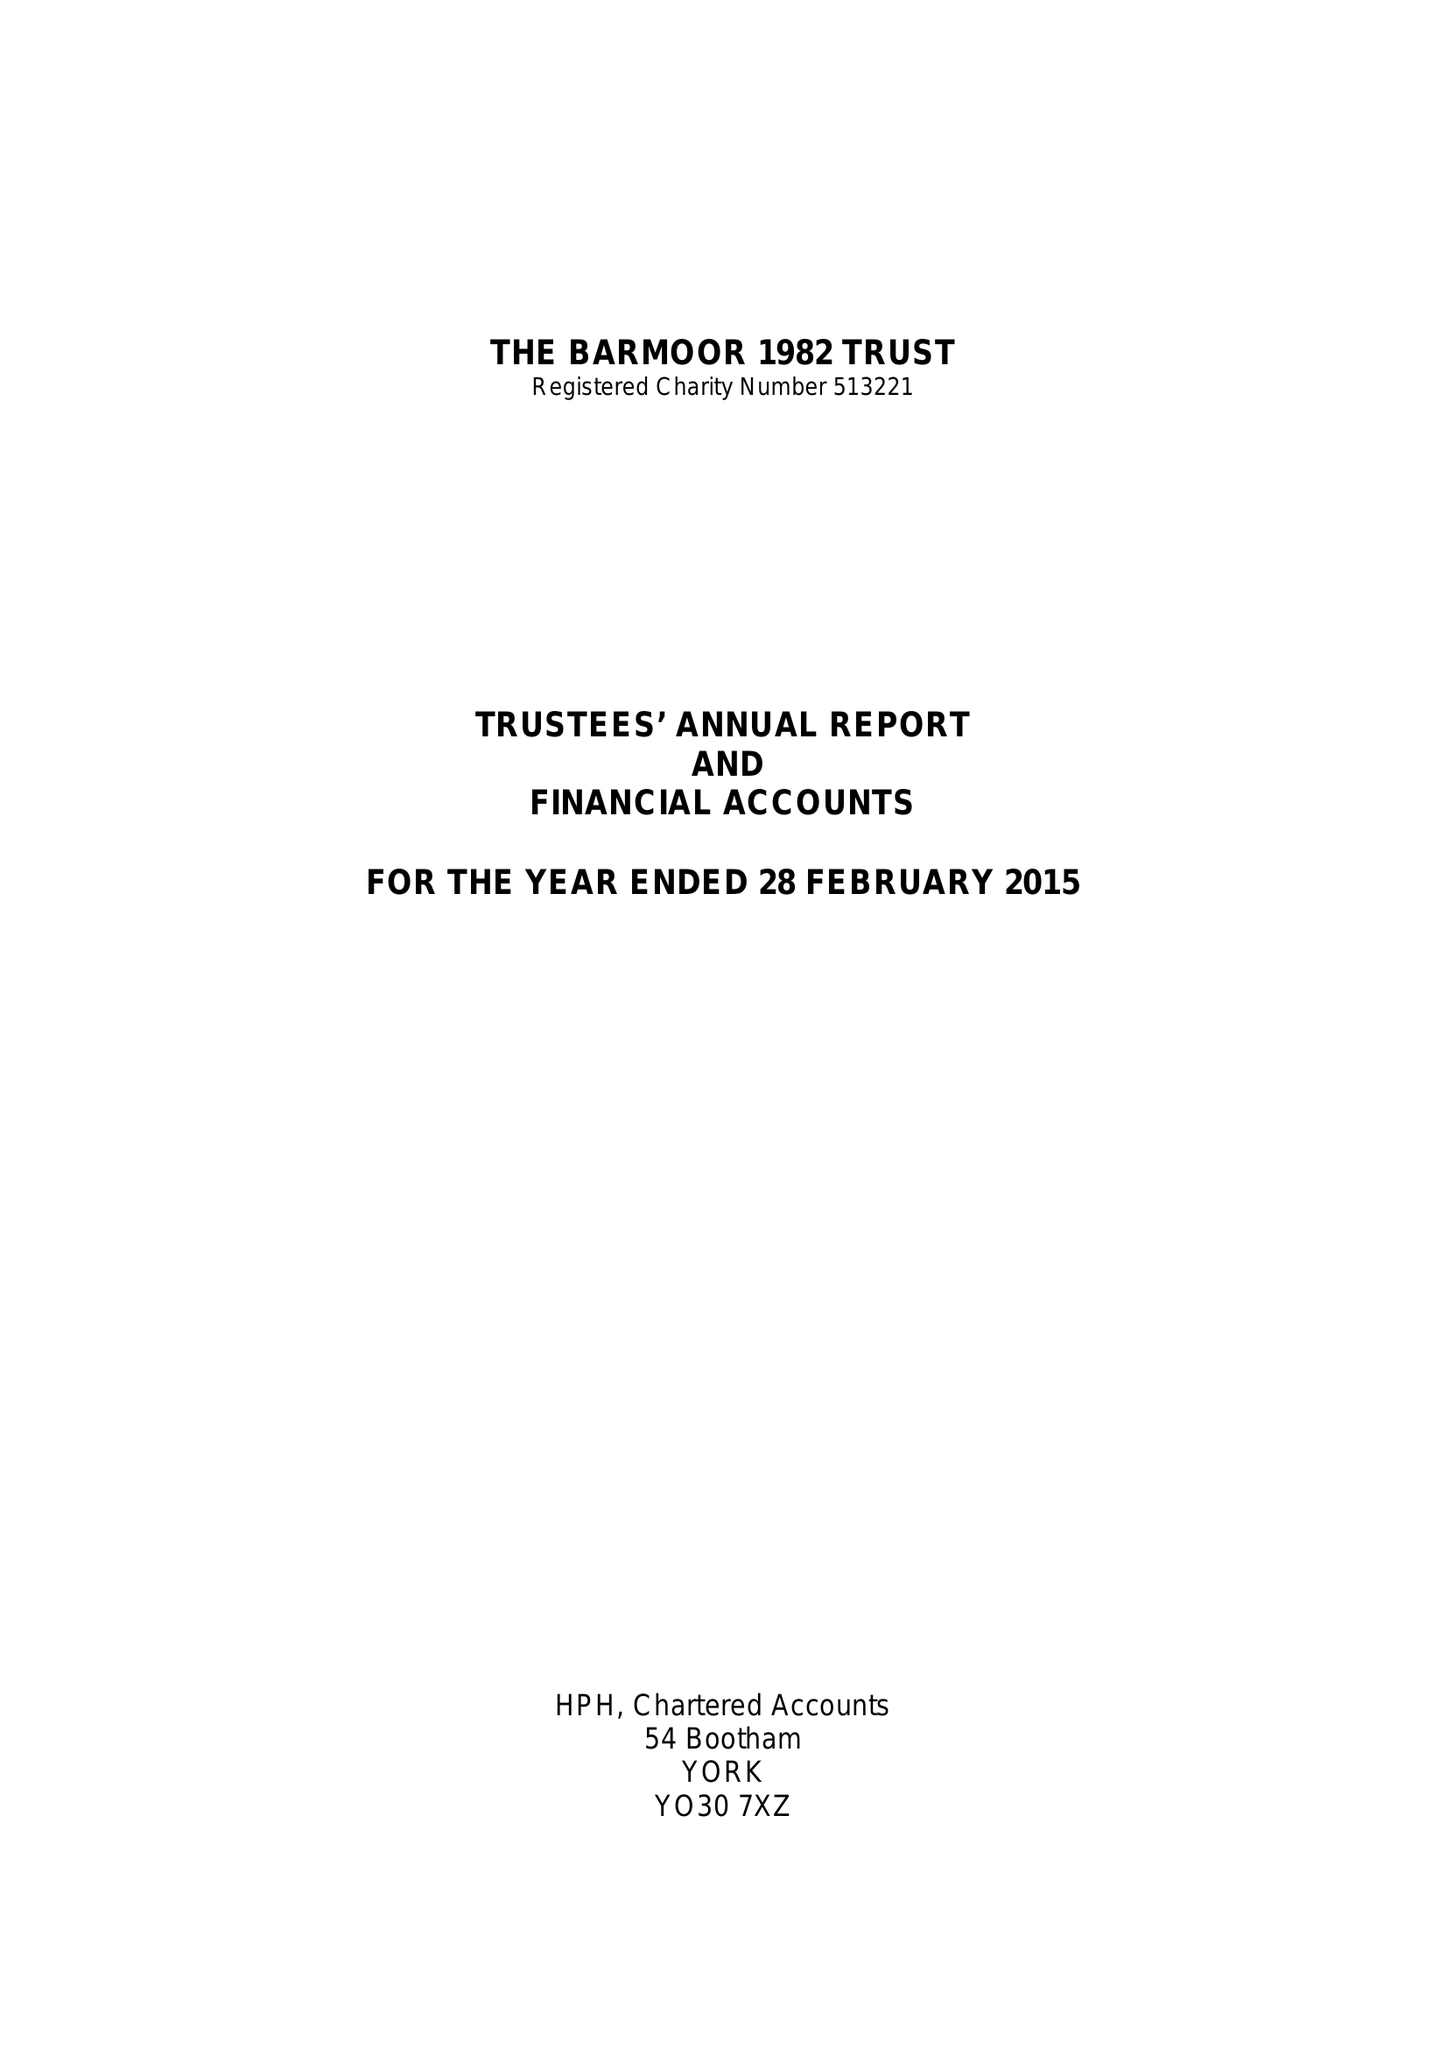What is the value for the charity_name?
Answer the question using a single word or phrase. The Barmoor 1982 Trust 